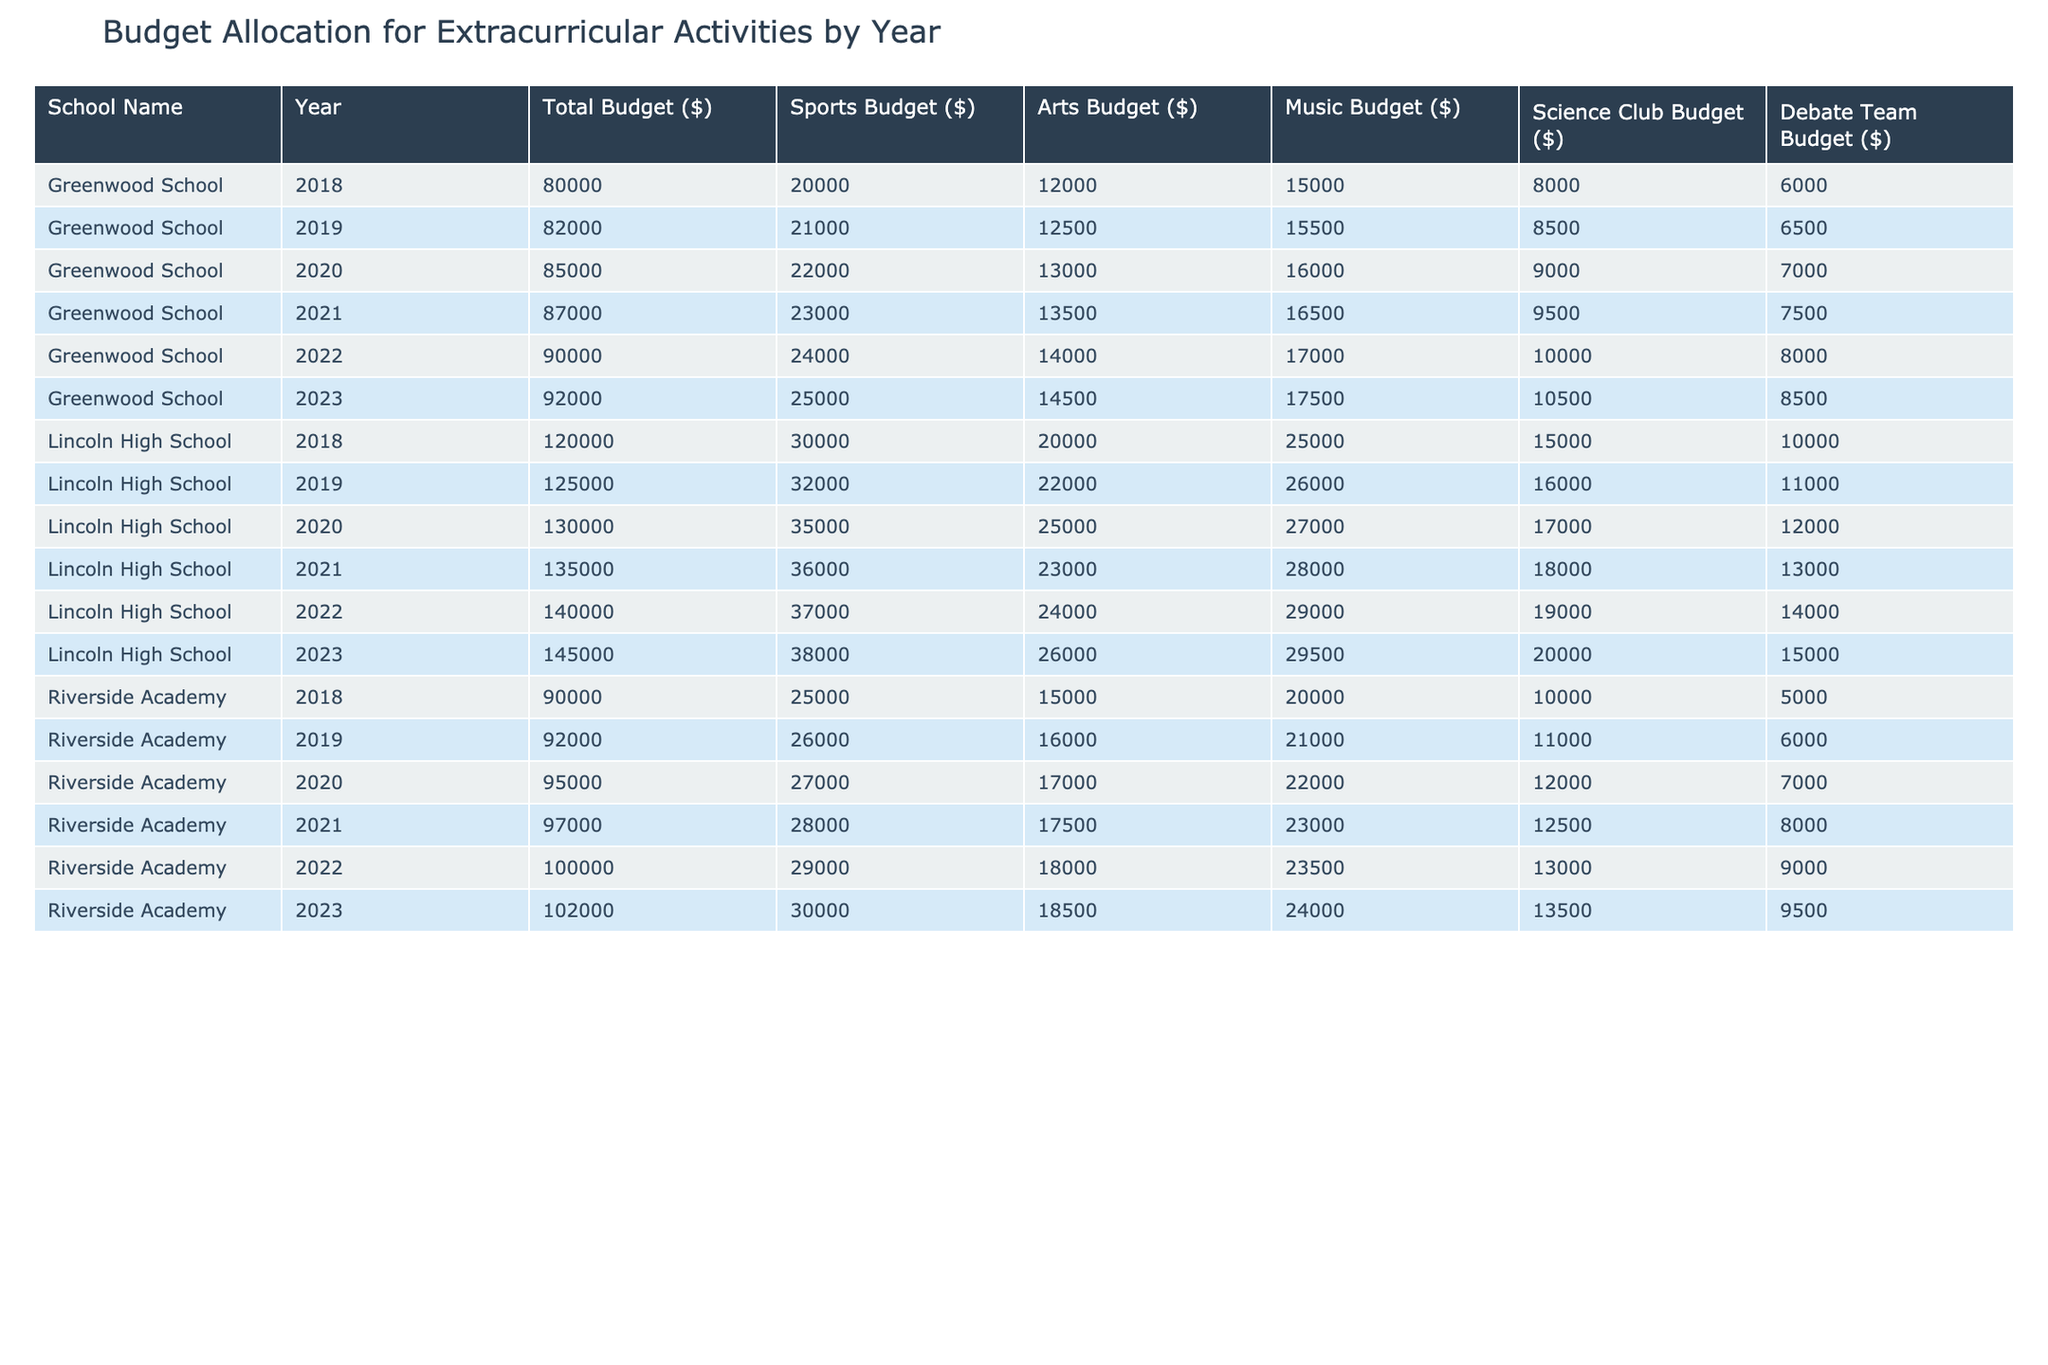What is the total budget allocated for Riverside Academy in 2021? From the table, we can see that the total budget for Riverside Academy in 2021 is listed directly under the "Total Budget ($)" column for that year. It states $97,000.
Answer: 97000 Which school had the highest sports budget in 2023? By checking the sports budget for each school in 2023, we find Lincoln High School has a sports budget of $38,000, Riverside Academy $30,000, and Greenwood School $25,000. Lincoln High School has the highest amount.
Answer: Lincoln High School What was the change in the Arts Budget for Greenwood School from 2018 to 2023? The Arts Budget for Greenwood School in 2018 was $12,000, and in 2023 it increased to $14,500. The change is calculated as $14,500 - $12,000 = $2,500.
Answer: 2500 What is the average budget allocated for the Debate Team across all schools in 2022? For 2022, the Debate Team budgets were Lincoln High School with $14,000, Riverside Academy with $9,000, and Greenwood School with $8,000. The total is $14,000 + $9,000 + $8,000 = $31,000. The average is $31,000 / 3 = $10,333.33.
Answer: 10333.33 Is the Science Club Budget for Lincoln High School higher than the total budget for Greenwood School in 2019? The Science Club budget for Lincoln High School in 2023 is $20,000, while Greenwood School's total budget in 2019 was $82,000. Since $20,000 < $82,000, the statement is false.
Answer: No How much more was spent on Sports at Riverside Academy in 2020 compared to 2019? The Sports Budgets for Riverside Academy are $26,000 in 2020 and $26,000 in 2019. The difference is $26,000 - $26,000 = $0, so there was no increase.
Answer: 0 What is the total budget for all schools in 2022? Summing the total budgets for all schools in 2022, we find Lincoln High School $140,000, Riverside Academy $100,000, and Greenwood School $90,000. The sum is $140,000 + $100,000 + $90,000 = $330,000.
Answer: 330000 Did the total budget for Lincoln High School increase every year from 2018 to 2023? By reviewing the total budgets for each year: 2018: $120,000, 2019: $125,000, 2020: $130,000, 2021: $135,000, 2022: $140,000, and 2023: $145,000, we see it increased each year without any decreases.
Answer: Yes Which school had the largest total budget in 2020? Lincoln High School's total budget in 2020 is $130,000, Riverside Academy's is $95,000, and Greenwood School's is $85,000. Therefore, Lincoln High School had the largest total budget.
Answer: Lincoln High School 